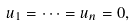Convert formula to latex. <formula><loc_0><loc_0><loc_500><loc_500>u _ { 1 } = \cdots = u _ { n } = 0 ,</formula> 